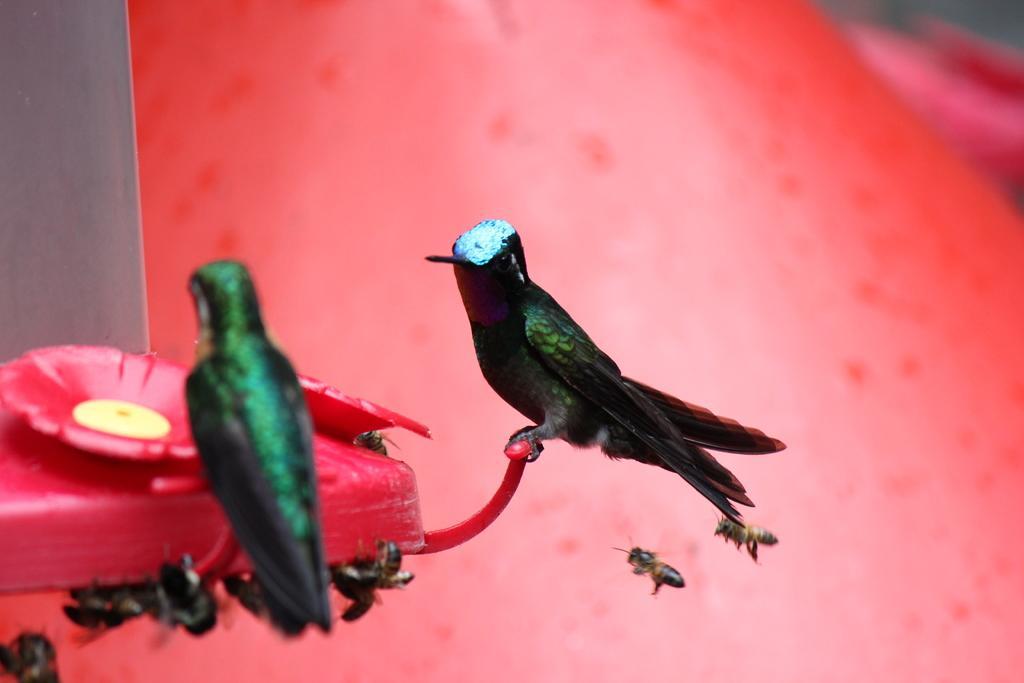Can you describe this image briefly? There is an object and on the object there are two birds and around object there are honey bees. 